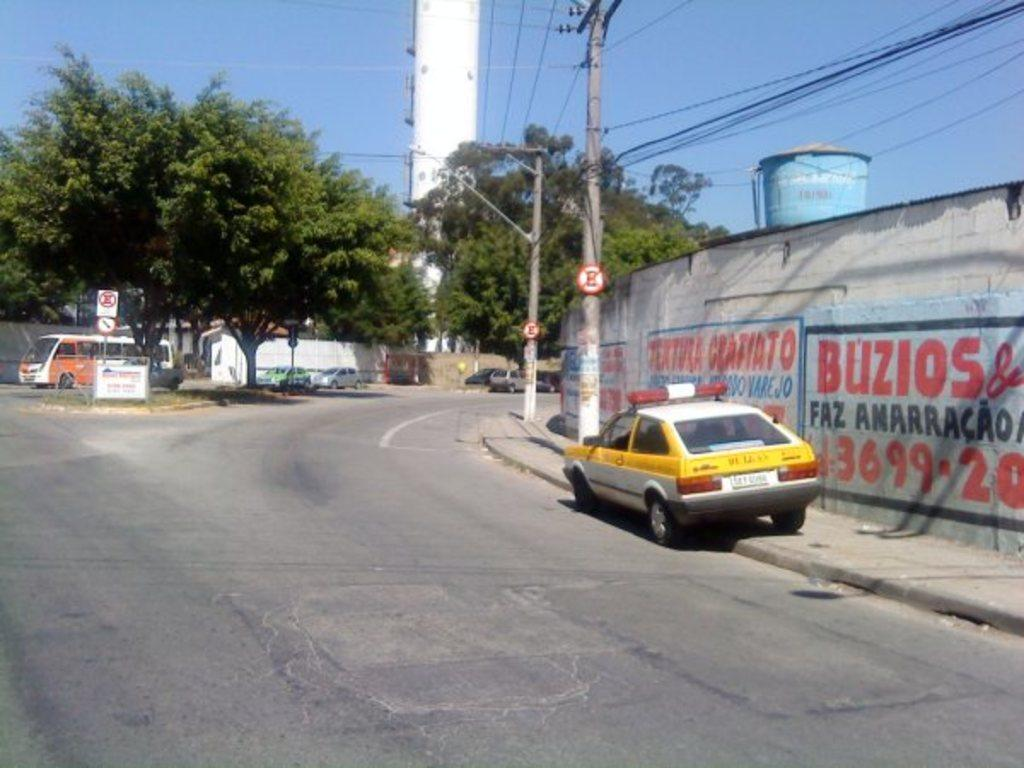Provide a one-sentence caption for the provided image. The white sign with the black border has the numbers 3699 written in red. 